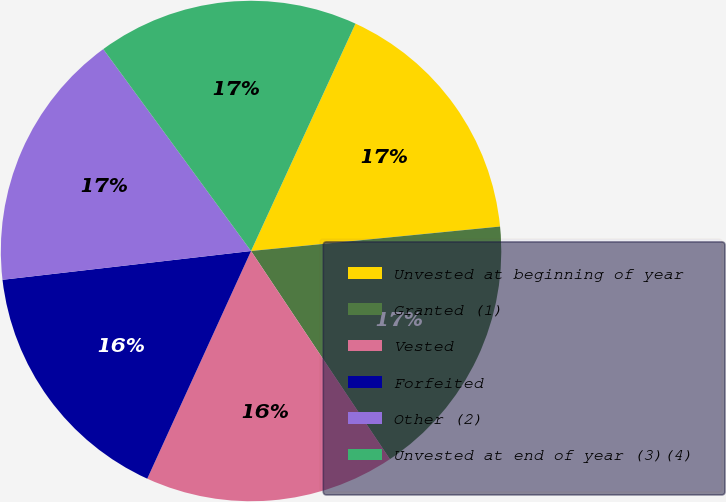<chart> <loc_0><loc_0><loc_500><loc_500><pie_chart><fcel>Unvested at beginning of year<fcel>Granted (1)<fcel>Vested<fcel>Forfeited<fcel>Other (2)<fcel>Unvested at end of year (3)(4)<nl><fcel>16.59%<fcel>17.2%<fcel>16.17%<fcel>16.36%<fcel>16.78%<fcel>16.91%<nl></chart> 